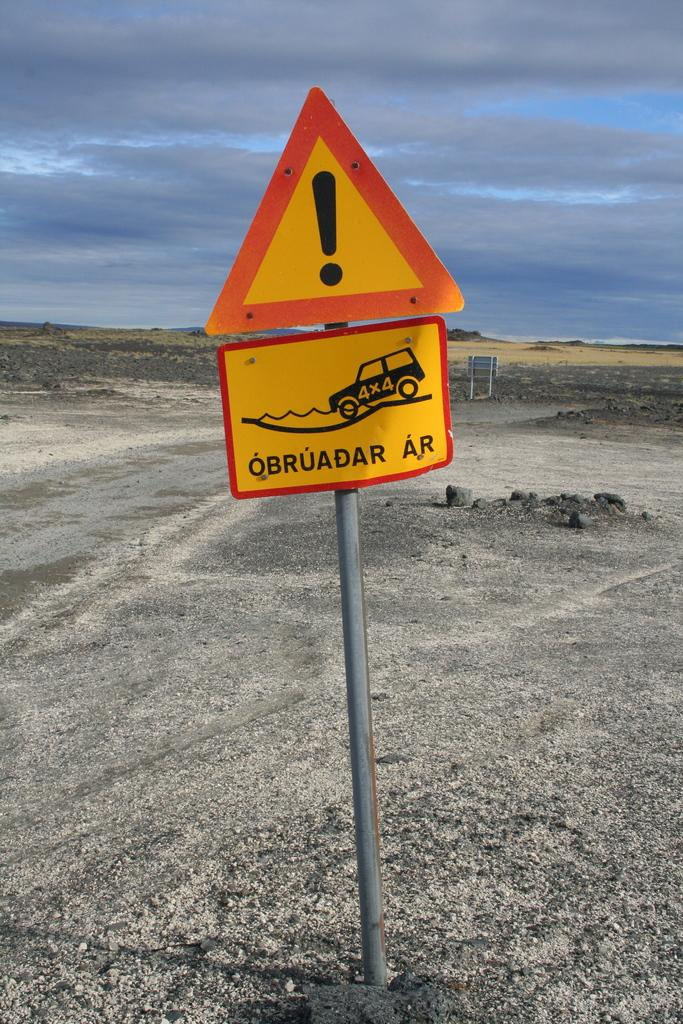Provide a one-sentence caption for the provided image. A caution sign with a 4x4 truck going into the water. 